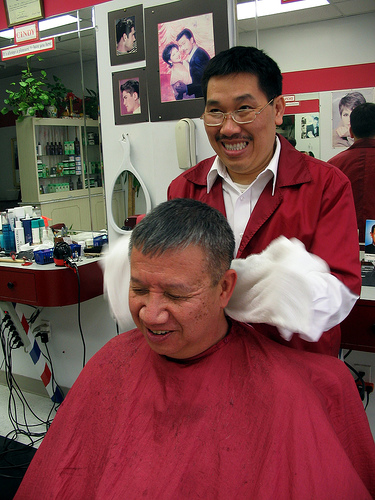<image>
Is there a head in front of the man? Yes. The head is positioned in front of the man, appearing closer to the camera viewpoint. 